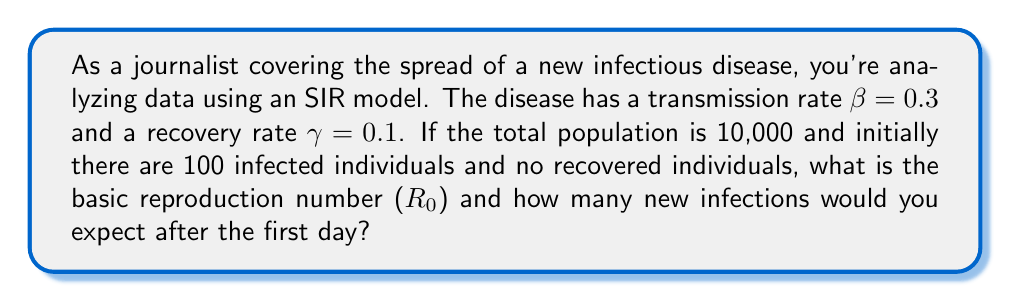Teach me how to tackle this problem. To solve this problem, we need to understand the SIR model and its parameters:

1. Calculate the basic reproduction number ($R_0$):
   The basic reproduction number is given by the formula:
   $$R_0 = \frac{\beta}{\gamma}$$
   Where $\beta$ is the transmission rate and $\gamma$ is the recovery rate.
   $$R_0 = \frac{0.3}{0.1} = 3$$

2. Calculate the number of susceptible individuals (S):
   $S = \text{Total population} - \text{Initially infected} - \text{Initially recovered}$
   $S = 10,000 - 100 - 0 = 9,900$

3. Calculate the number of new infections after the first day:
   In the SIR model, the rate of new infections is given by:
   $$\frac{dI}{dt} = \beta SI - \gamma I$$
   Where $S$ is the number of susceptible individuals and $I$ is the number of infected individuals.

   For a discrete time step of one day, we can approximate this as:
   $$\text{New infections} \approx \beta SI - \gamma I$$

   Plugging in the values:
   $$\text{New infections} \approx (0.3 \times 9,900 \times 100) - (0.1 \times 100)$$
   $$\text{New infections} \approx 297,000 - 10 = 296,990$$

   However, this number exceeds the total population, which is impossible. In reality, the number of new infections is limited by the available susceptible population. Therefore, the actual number of new infections would be:

   $$\text{New infections} = \min(296,990, 9,900) = 9,900$$
Answer: The basic reproduction number ($R_0$) is 3, and the number of new infections expected after the first day is 9,900. 